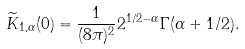<formula> <loc_0><loc_0><loc_500><loc_500>\widetilde { K } _ { 1 , \alpha } ( 0 ) = \frac { 1 } { ( 8 \pi ) ^ { 2 } } 2 ^ { 1 / 2 - \alpha } \Gamma ( \alpha + 1 / 2 ) .</formula> 